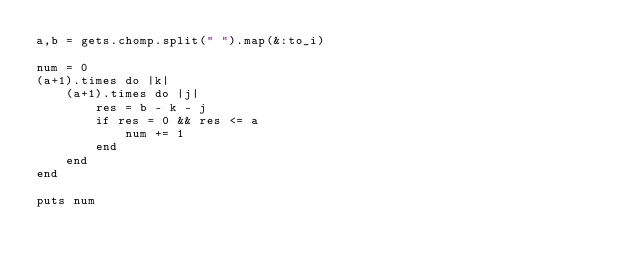Convert code to text. <code><loc_0><loc_0><loc_500><loc_500><_Ruby_>a,b = gets.chomp.split(" ").map(&:to_i)

num = 0
(a+1).times do |k|
    (a+1).times do |j|
        res = b - k - j
        if res = 0 && res <= a
            num += 1
        end
    end
end

puts num</code> 